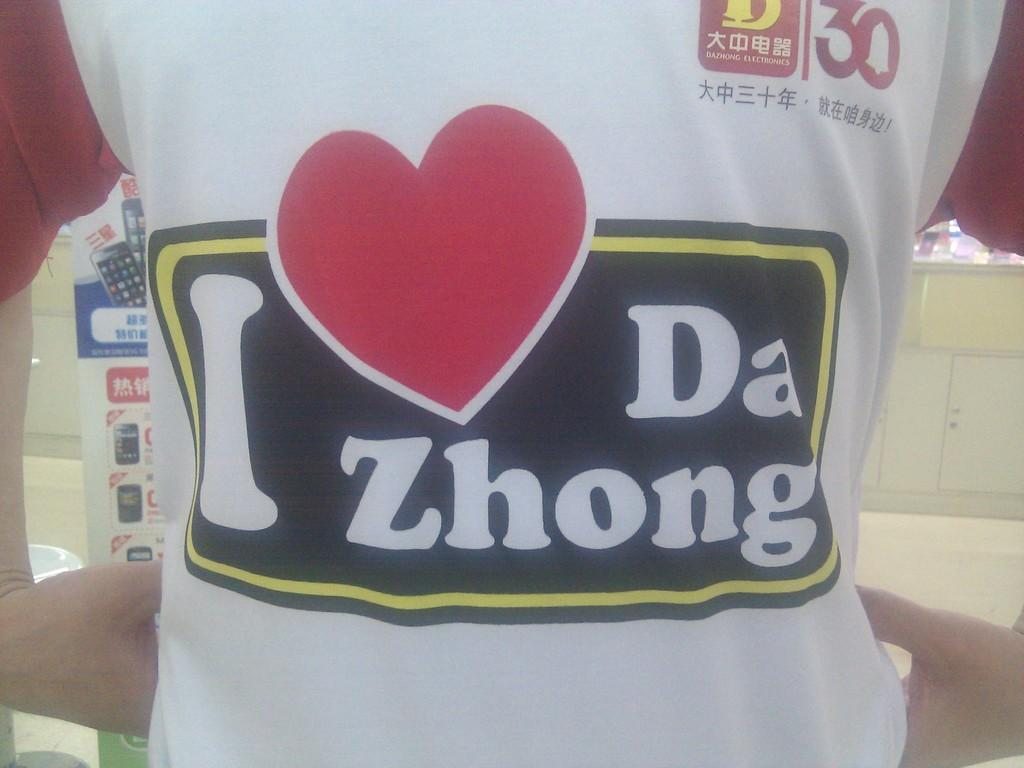<image>
Summarize the visual content of the image. A white t-shirts displays an I heart Da Zhong decal. 